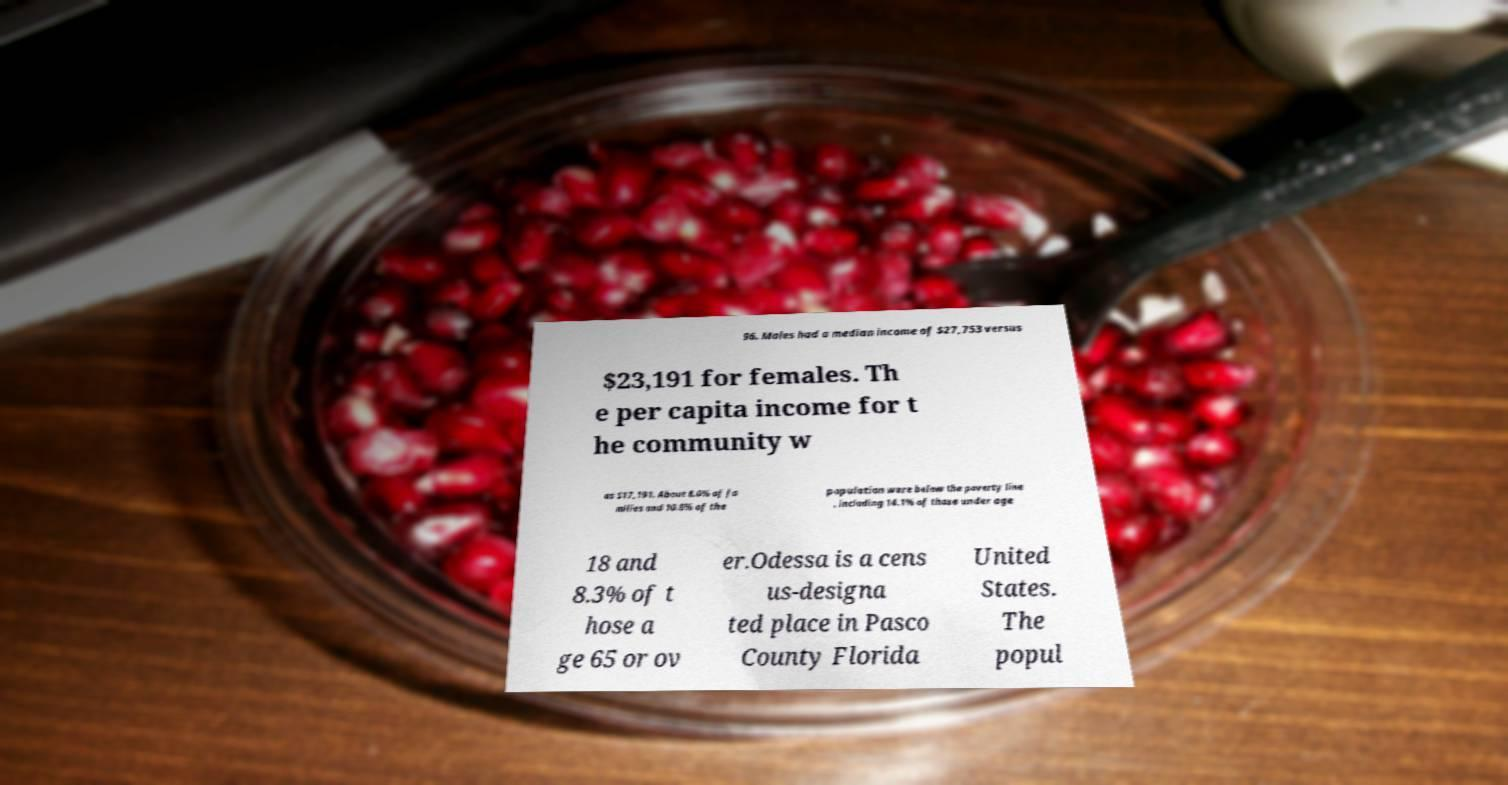There's text embedded in this image that I need extracted. Can you transcribe it verbatim? 96. Males had a median income of $27,753 versus $23,191 for females. Th e per capita income for t he community w as $17,191. About 8.0% of fa milies and 10.8% of the population were below the poverty line , including 14.1% of those under age 18 and 8.3% of t hose a ge 65 or ov er.Odessa is a cens us-designa ted place in Pasco County Florida United States. The popul 